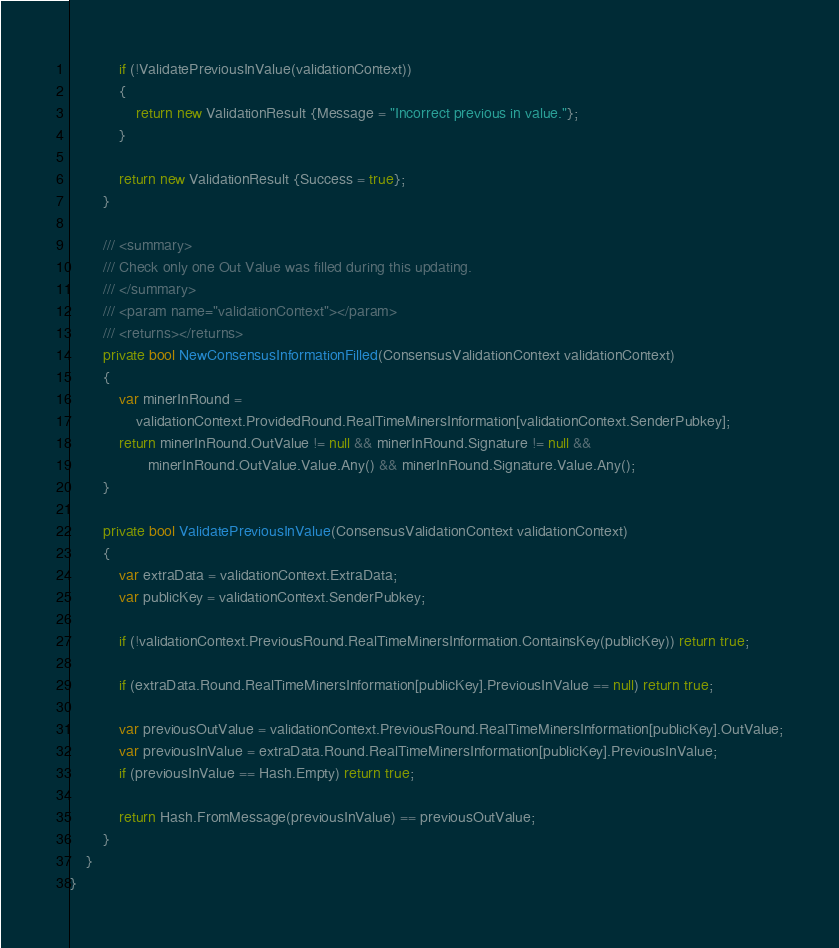Convert code to text. <code><loc_0><loc_0><loc_500><loc_500><_C#_>
            if (!ValidatePreviousInValue(validationContext))
            {
                return new ValidationResult {Message = "Incorrect previous in value."};
            }

            return new ValidationResult {Success = true};
        }

        /// <summary>
        /// Check only one Out Value was filled during this updating.
        /// </summary>
        /// <param name="validationContext"></param>
        /// <returns></returns>
        private bool NewConsensusInformationFilled(ConsensusValidationContext validationContext)
        {
            var minerInRound =
                validationContext.ProvidedRound.RealTimeMinersInformation[validationContext.SenderPubkey];
            return minerInRound.OutValue != null && minerInRound.Signature != null &&
                   minerInRound.OutValue.Value.Any() && minerInRound.Signature.Value.Any();
        }

        private bool ValidatePreviousInValue(ConsensusValidationContext validationContext)
        {
            var extraData = validationContext.ExtraData;
            var publicKey = validationContext.SenderPubkey;

            if (!validationContext.PreviousRound.RealTimeMinersInformation.ContainsKey(publicKey)) return true;

            if (extraData.Round.RealTimeMinersInformation[publicKey].PreviousInValue == null) return true;

            var previousOutValue = validationContext.PreviousRound.RealTimeMinersInformation[publicKey].OutValue;
            var previousInValue = extraData.Round.RealTimeMinersInformation[publicKey].PreviousInValue;
            if (previousInValue == Hash.Empty) return true;

            return Hash.FromMessage(previousInValue) == previousOutValue;
        }
    }
}</code> 